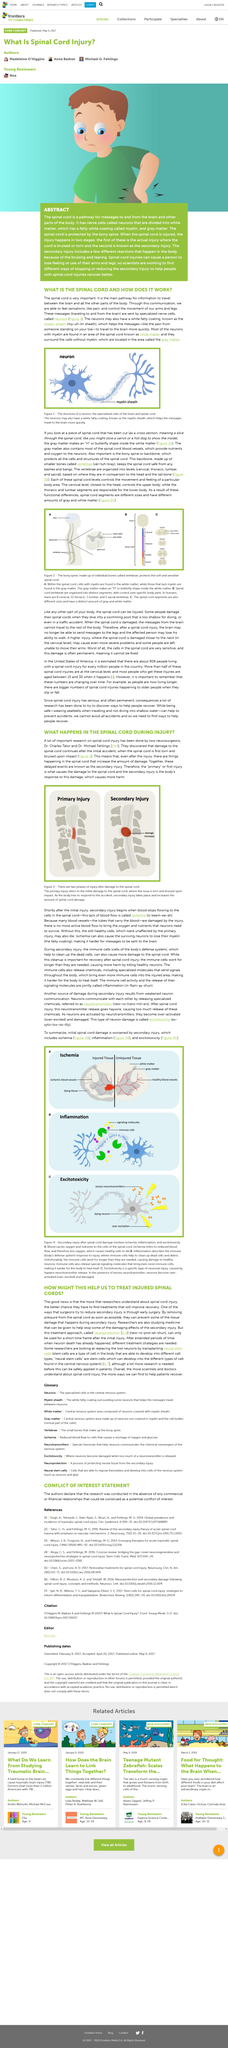List a handful of essential elements in this visual. Excitotoxicity is a form of neuron damage caused by excessive excitation of neurons. The worsening of spinal cord injuries is due to secondary damage. Neurotransmitters are chemicals that neurons release to facilitate communication with each other. The two phases of spinal cord injury, primary injury and secondary injury, are depicted in Figure 3. Myelin sheath is the white fatty coating of neurons that is known. 